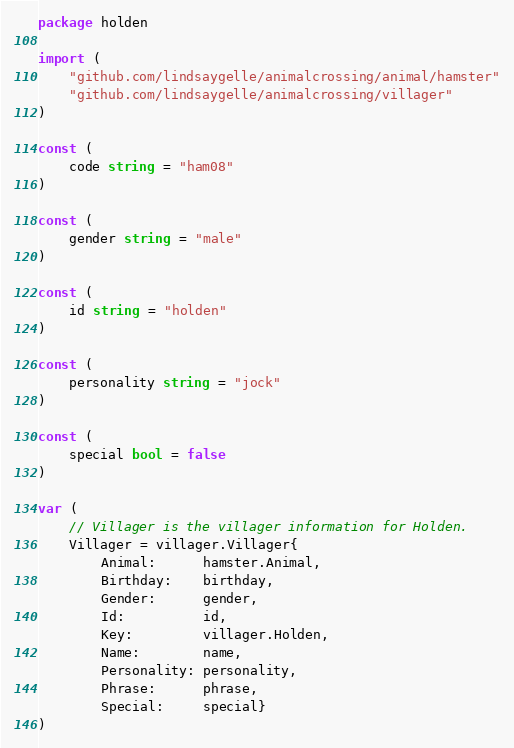<code> <loc_0><loc_0><loc_500><loc_500><_Go_>package holden

import (
	"github.com/lindsaygelle/animalcrossing/animal/hamster"
	"github.com/lindsaygelle/animalcrossing/villager"
)

const (
	code string = "ham08"
)

const (
	gender string = "male"
)

const (
	id string = "holden"
)

const (
	personality string = "jock"
)

const (
	special bool = false
)

var (
	// Villager is the villager information for Holden.
	Villager = villager.Villager{
		Animal:      hamster.Animal,
		Birthday:    birthday,
		Gender:      gender,
		Id:          id,
		Key:         villager.Holden,
		Name:        name,
		Personality: personality,
		Phrase:      phrase,
		Special:     special}
)
</code> 